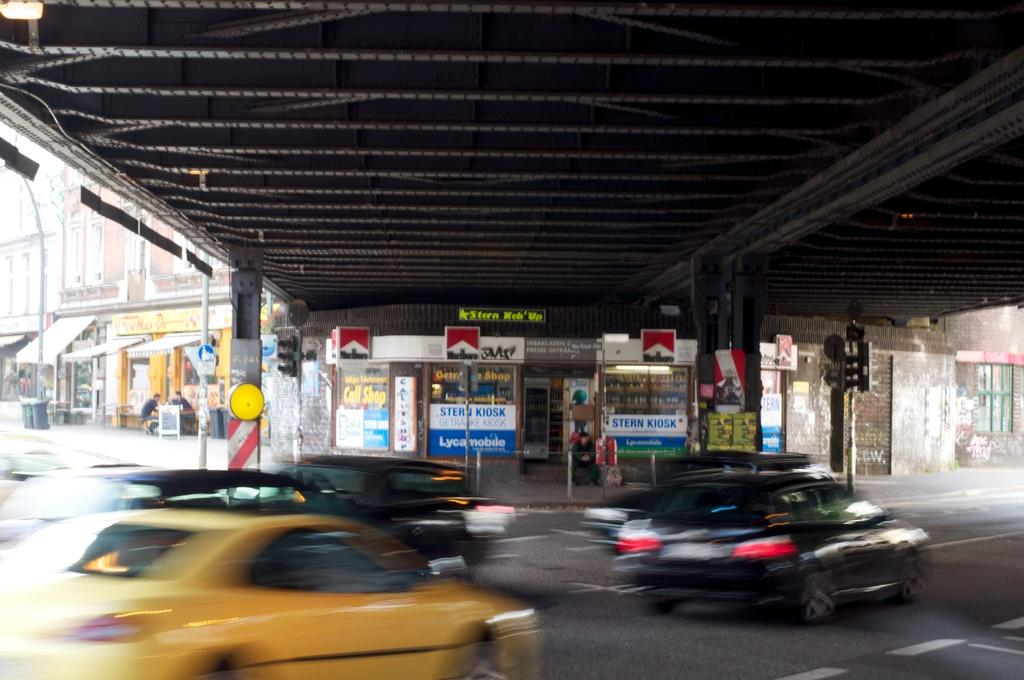<image>
Present a compact description of the photo's key features. The sign outside the store is advertising for Marlboro 